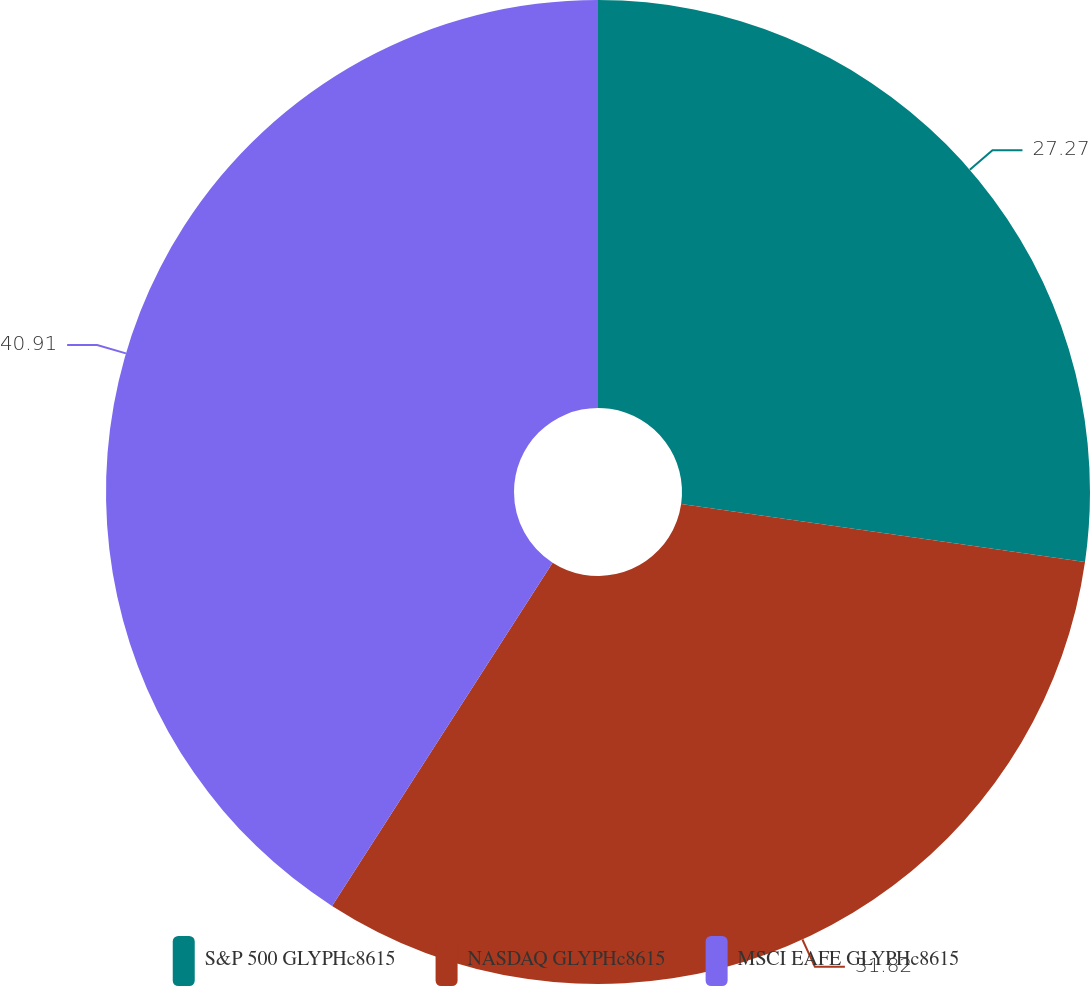<chart> <loc_0><loc_0><loc_500><loc_500><pie_chart><fcel>S&P 500 GLYPHc8615<fcel>NASDAQ GLYPHc8615<fcel>MSCI EAFE GLYPHc8615<nl><fcel>27.27%<fcel>31.82%<fcel>40.91%<nl></chart> 